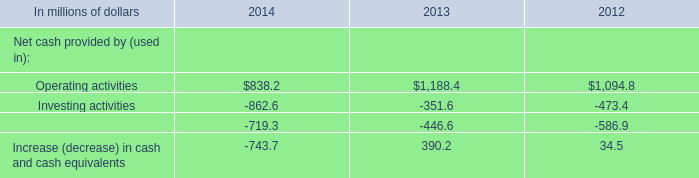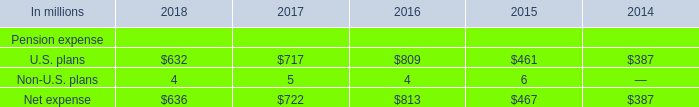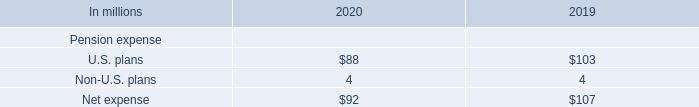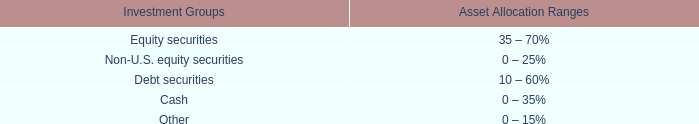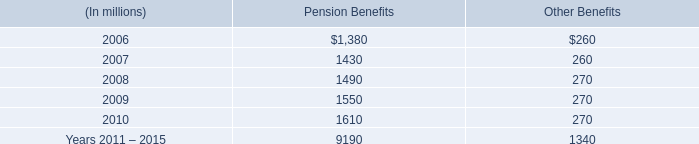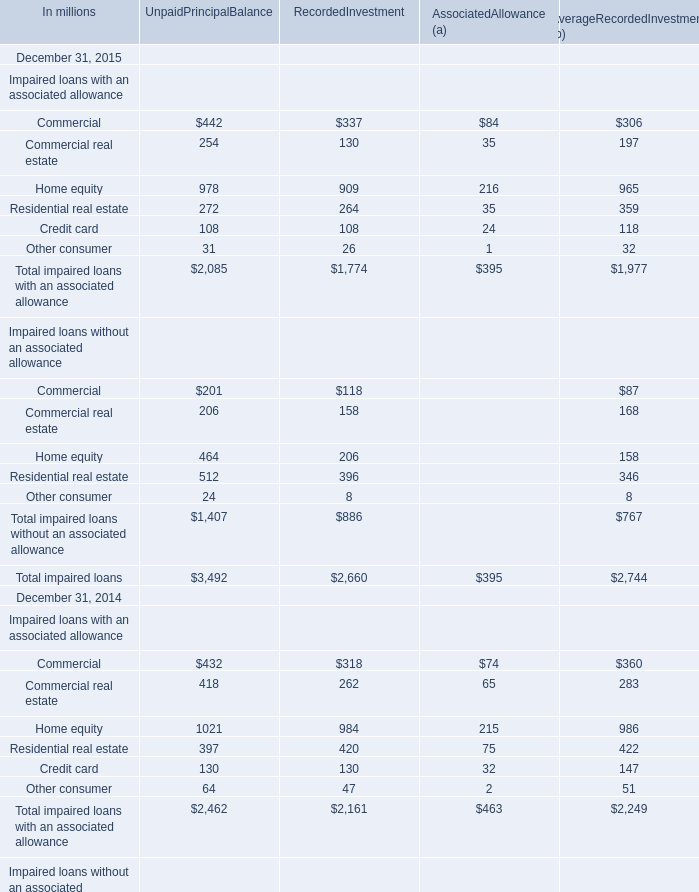How many element keeps increasing each year between 2014 and 2015 ? 
Answer: 3. 